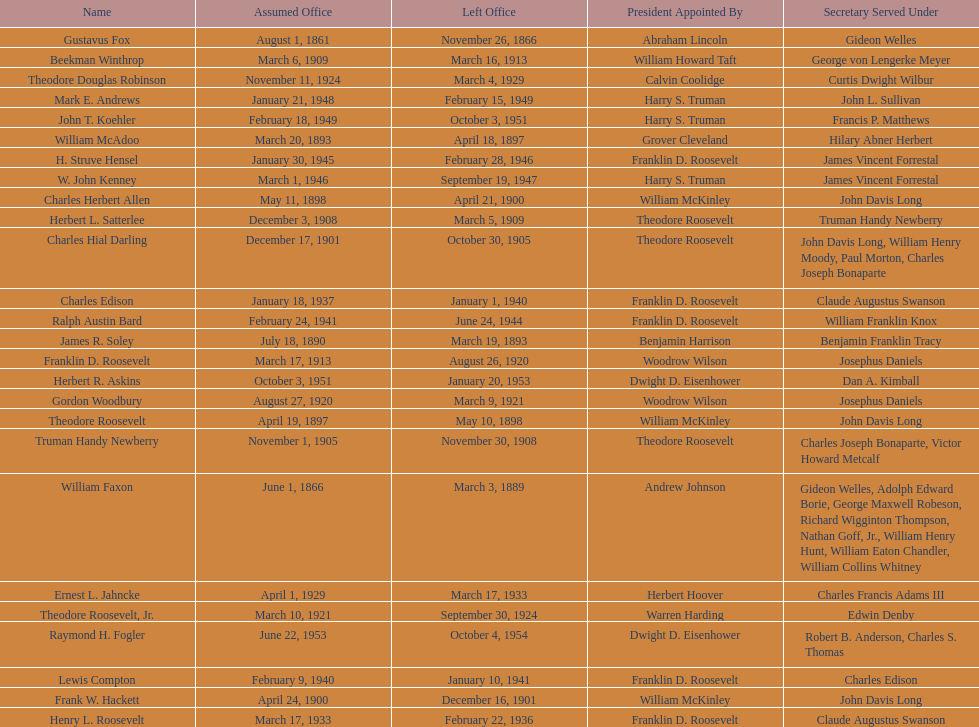Write the full table. {'header': ['Name', 'Assumed Office', 'Left Office', 'President Appointed By', 'Secretary Served Under'], 'rows': [['Gustavus Fox', 'August 1, 1861', 'November 26, 1866', 'Abraham Lincoln', 'Gideon Welles'], ['Beekman Winthrop', 'March 6, 1909', 'March 16, 1913', 'William Howard Taft', 'George von Lengerke Meyer'], ['Theodore Douglas Robinson', 'November 11, 1924', 'March 4, 1929', 'Calvin Coolidge', 'Curtis Dwight Wilbur'], ['Mark E. Andrews', 'January 21, 1948', 'February 15, 1949', 'Harry S. Truman', 'John L. Sullivan'], ['John T. Koehler', 'February 18, 1949', 'October 3, 1951', 'Harry S. Truman', 'Francis P. Matthews'], ['William McAdoo', 'March 20, 1893', 'April 18, 1897', 'Grover Cleveland', 'Hilary Abner Herbert'], ['H. Struve Hensel', 'January 30, 1945', 'February 28, 1946', 'Franklin D. Roosevelt', 'James Vincent Forrestal'], ['W. John Kenney', 'March 1, 1946', 'September 19, 1947', 'Harry S. Truman', 'James Vincent Forrestal'], ['Charles Herbert Allen', 'May 11, 1898', 'April 21, 1900', 'William McKinley', 'John Davis Long'], ['Herbert L. Satterlee', 'December 3, 1908', 'March 5, 1909', 'Theodore Roosevelt', 'Truman Handy Newberry'], ['Charles Hial Darling', 'December 17, 1901', 'October 30, 1905', 'Theodore Roosevelt', 'John Davis Long, William Henry Moody, Paul Morton, Charles Joseph Bonaparte'], ['Charles Edison', 'January 18, 1937', 'January 1, 1940', 'Franklin D. Roosevelt', 'Claude Augustus Swanson'], ['Ralph Austin Bard', 'February 24, 1941', 'June 24, 1944', 'Franklin D. Roosevelt', 'William Franklin Knox'], ['James R. Soley', 'July 18, 1890', 'March 19, 1893', 'Benjamin Harrison', 'Benjamin Franklin Tracy'], ['Franklin D. Roosevelt', 'March 17, 1913', 'August 26, 1920', 'Woodrow Wilson', 'Josephus Daniels'], ['Herbert R. Askins', 'October 3, 1951', 'January 20, 1953', 'Dwight D. Eisenhower', 'Dan A. Kimball'], ['Gordon Woodbury', 'August 27, 1920', 'March 9, 1921', 'Woodrow Wilson', 'Josephus Daniels'], ['Theodore Roosevelt', 'April 19, 1897', 'May 10, 1898', 'William McKinley', 'John Davis Long'], ['Truman Handy Newberry', 'November 1, 1905', 'November 30, 1908', 'Theodore Roosevelt', 'Charles Joseph Bonaparte, Victor Howard Metcalf'], ['William Faxon', 'June 1, 1866', 'March 3, 1889', 'Andrew Johnson', 'Gideon Welles, Adolph Edward Borie, George Maxwell Robeson, Richard Wigginton Thompson, Nathan Goff, Jr., William Henry Hunt, William Eaton Chandler, William Collins Whitney'], ['Ernest L. Jahncke', 'April 1, 1929', 'March 17, 1933', 'Herbert Hoover', 'Charles Francis Adams III'], ['Theodore Roosevelt, Jr.', 'March 10, 1921', 'September 30, 1924', 'Warren Harding', 'Edwin Denby'], ['Raymond H. Fogler', 'June 22, 1953', 'October 4, 1954', 'Dwight D. Eisenhower', 'Robert B. Anderson, Charles S. Thomas'], ['Lewis Compton', 'February 9, 1940', 'January 10, 1941', 'Franklin D. Roosevelt', 'Charles Edison'], ['Frank W. Hackett', 'April 24, 1900', 'December 16, 1901', 'William McKinley', 'John Davis Long'], ['Henry L. Roosevelt', 'March 17, 1933', 'February 22, 1936', 'Franklin D. Roosevelt', 'Claude Augustus Swanson']]} When did raymond h. fogler leave the office of assistant secretary of the navy? October 4, 1954. 